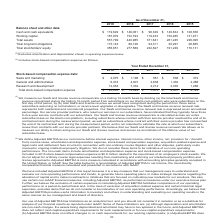According to Alarmcom Holdings's financial document, What were the cash and cash equivalents in 2019? According to the financial document, $119,629 (in thousands). The relevant text states: "sheet and other data: Cash and cash equivalents $ 119,629 $ 146,061 $ 96,329 $ 140,634 $ 128,358 Working capital 167,879 152,793 119,433 150,485 131,971 Tota..." Also, What was the working capital in 2018? According to the financial document, 152,793 (in thousands). The relevant text states: "6,329 $ 140,634 $ 128,358 Working capital 167,879 152,793 119,433 150,485 131,971 Total assets 557,799 440,985 371,641 261,245 226,095 Total long-term obliga..." Also, Which years does the table provide data for total assets? The document contains multiple relevant values: 2019, 2018, 2017, 2016, 2015. From the document: "As of December 31, 2019 2018 2017 2016 2015 Balance sheet and other data: Cash and cash equivalents $ 119,629 $ 146,061 $ 96,329 As of December 31, 20..." Also, can you calculate: What was the change in working capital between 2015 and 2016? Based on the calculation: 150,485-131,971, the result is 18514 (in thousands). This is based on the information: "$ 128,358 Working capital 167,879 152,793 119,433 150,485 131,971 Total assets 557,799 440,985 371,641 261,245 226,095 Total long-term obligations 115,143 88 8 Working capital 167,879 152,793 119,433 ..." The key data points involved are: 131,971, 150,485. Also, can you calculate: What was the change in total stockholders' equity between 2016 and 2017? Based on the calculation: 232,827-191,249, the result is 41578 (in thousands). This is based on the information: "26,885 Total stockholders' equity 355,651 277,589 232,827 191,249 170,131 otal stockholders' equity 355,651 277,589 232,827 191,249 170,131..." The key data points involved are: 191,249, 232,827. Also, can you calculate: What was the percentage change in the total assets between 2018 and 2019? To answer this question, I need to perform calculations using the financial data. The calculation is: (557,799-440,985)/440,985, which equals 26.49 (percentage). This is based on the information: ",879 152,793 119,433 150,485 131,971 Total assets 557,799 440,985 371,641 261,245 226,095 Total long-term obligations 115,143 88,126 94,311 30,297 26,885 Tot ,793 119,433 150,485 131,971 Total assets ..." The key data points involved are: 440,985, 557,799. 